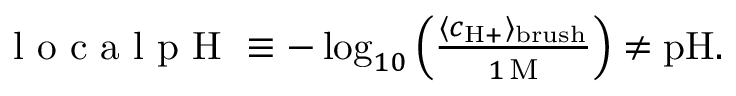<formula> <loc_0><loc_0><loc_500><loc_500>\begin{array} { r } { l o c a l p H \equiv - \log _ { 1 0 } \left ( \frac { \langle c _ { H + } \rangle _ { b r u s h } } { 1 \, M } \right ) \neq p H . } \end{array}</formula> 